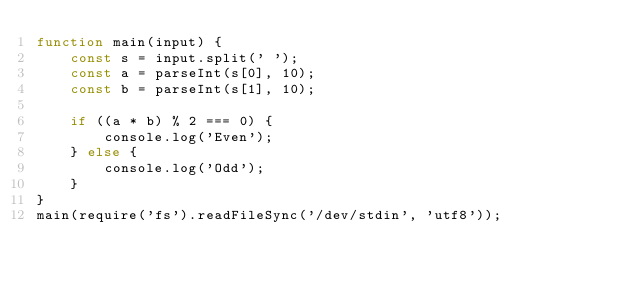<code> <loc_0><loc_0><loc_500><loc_500><_JavaScript_>function main(input) {
    const s = input.split(' ');
    const a = parseInt(s[0], 10);
    const b = parseInt(s[1], 10);

    if ((a * b) % 2 === 0) {
        console.log('Even');
    } else {
        console.log('Odd');
    }
}
main(require('fs').readFileSync('/dev/stdin', 'utf8'));

</code> 